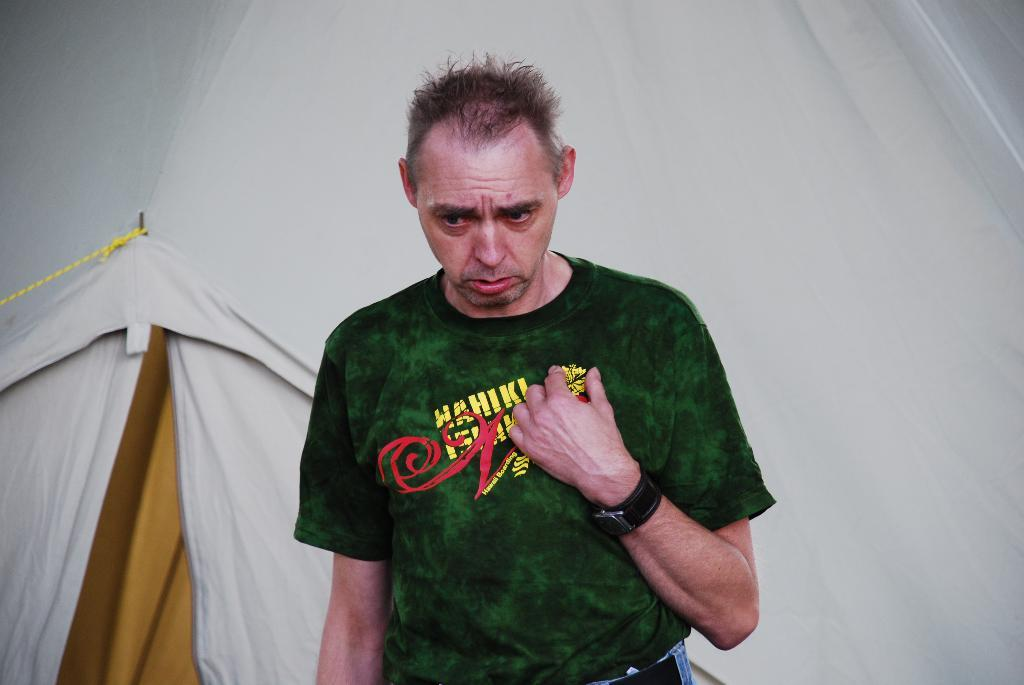What is the main subject in the foreground of the image? There is a man standing in the foreground of the image. What can be seen in the background of the image? There is a curtain and a rope in the background of the image. What type of operation is being performed by the man in the image? There is no indication of an operation or any medical procedure in the image; it simply shows a man standing in the foreground. 